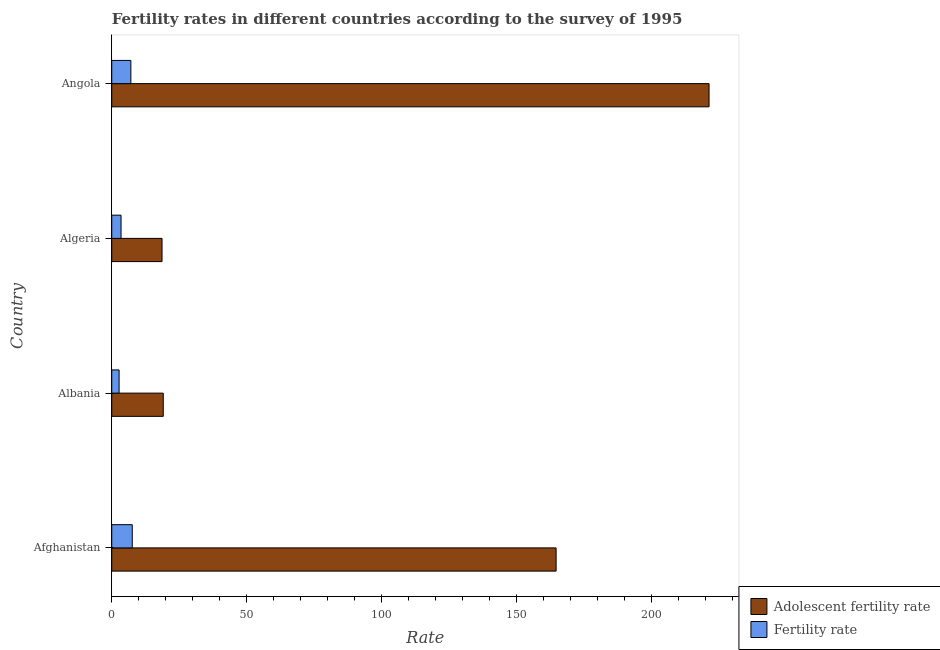Are the number of bars on each tick of the Y-axis equal?
Your answer should be compact. Yes. How many bars are there on the 1st tick from the top?
Your answer should be compact. 2. What is the label of the 4th group of bars from the top?
Keep it short and to the point. Afghanistan. What is the adolescent fertility rate in Albania?
Your response must be concise. 19.09. Across all countries, what is the maximum adolescent fertility rate?
Give a very brief answer. 221.4. Across all countries, what is the minimum fertility rate?
Keep it short and to the point. 2.72. In which country was the fertility rate maximum?
Your response must be concise. Afghanistan. In which country was the fertility rate minimum?
Offer a terse response. Albania. What is the total adolescent fertility rate in the graph?
Ensure brevity in your answer.  423.84. What is the difference between the adolescent fertility rate in Albania and that in Algeria?
Make the answer very short. 0.45. What is the difference between the adolescent fertility rate in Albania and the fertility rate in Afghanistan?
Your response must be concise. 11.49. What is the average adolescent fertility rate per country?
Provide a succinct answer. 105.96. What is the difference between the adolescent fertility rate and fertility rate in Algeria?
Offer a very short reply. 15.19. What is the ratio of the adolescent fertility rate in Algeria to that in Angola?
Your response must be concise. 0.08. Is the adolescent fertility rate in Albania less than that in Angola?
Provide a succinct answer. Yes. Is the difference between the adolescent fertility rate in Afghanistan and Angola greater than the difference between the fertility rate in Afghanistan and Angola?
Your answer should be compact. No. What is the difference between the highest and the second highest adolescent fertility rate?
Provide a short and direct response. 56.69. What is the difference between the highest and the lowest adolescent fertility rate?
Give a very brief answer. 202.76. In how many countries, is the adolescent fertility rate greater than the average adolescent fertility rate taken over all countries?
Keep it short and to the point. 2. What does the 2nd bar from the top in Algeria represents?
Keep it short and to the point. Adolescent fertility rate. What does the 2nd bar from the bottom in Algeria represents?
Your response must be concise. Fertility rate. How many countries are there in the graph?
Offer a terse response. 4. Does the graph contain grids?
Your response must be concise. No. What is the title of the graph?
Provide a short and direct response. Fertility rates in different countries according to the survey of 1995. Does "Primary income" appear as one of the legend labels in the graph?
Offer a very short reply. No. What is the label or title of the X-axis?
Give a very brief answer. Rate. What is the label or title of the Y-axis?
Provide a short and direct response. Country. What is the Rate of Adolescent fertility rate in Afghanistan?
Keep it short and to the point. 164.71. What is the Rate in Fertility rate in Afghanistan?
Keep it short and to the point. 7.61. What is the Rate of Adolescent fertility rate in Albania?
Make the answer very short. 19.09. What is the Rate in Fertility rate in Albania?
Ensure brevity in your answer.  2.72. What is the Rate of Adolescent fertility rate in Algeria?
Your answer should be compact. 18.64. What is the Rate of Fertility rate in Algeria?
Provide a succinct answer. 3.45. What is the Rate in Adolescent fertility rate in Angola?
Provide a succinct answer. 221.4. What is the Rate in Fertility rate in Angola?
Keep it short and to the point. 7.08. Across all countries, what is the maximum Rate in Adolescent fertility rate?
Make the answer very short. 221.4. Across all countries, what is the maximum Rate of Fertility rate?
Ensure brevity in your answer.  7.61. Across all countries, what is the minimum Rate of Adolescent fertility rate?
Provide a succinct answer. 18.64. Across all countries, what is the minimum Rate of Fertility rate?
Keep it short and to the point. 2.72. What is the total Rate of Adolescent fertility rate in the graph?
Provide a short and direct response. 423.84. What is the total Rate of Fertility rate in the graph?
Keep it short and to the point. 20.86. What is the difference between the Rate of Adolescent fertility rate in Afghanistan and that in Albania?
Your answer should be very brief. 145.62. What is the difference between the Rate in Fertility rate in Afghanistan and that in Albania?
Your answer should be very brief. 4.88. What is the difference between the Rate of Adolescent fertility rate in Afghanistan and that in Algeria?
Keep it short and to the point. 146.07. What is the difference between the Rate in Fertility rate in Afghanistan and that in Algeria?
Give a very brief answer. 4.16. What is the difference between the Rate in Adolescent fertility rate in Afghanistan and that in Angola?
Provide a succinct answer. -56.69. What is the difference between the Rate in Fertility rate in Afghanistan and that in Angola?
Make the answer very short. 0.52. What is the difference between the Rate of Adolescent fertility rate in Albania and that in Algeria?
Give a very brief answer. 0.45. What is the difference between the Rate of Fertility rate in Albania and that in Algeria?
Give a very brief answer. -0.72. What is the difference between the Rate in Adolescent fertility rate in Albania and that in Angola?
Offer a very short reply. -202.31. What is the difference between the Rate of Fertility rate in Albania and that in Angola?
Ensure brevity in your answer.  -4.36. What is the difference between the Rate in Adolescent fertility rate in Algeria and that in Angola?
Give a very brief answer. -202.76. What is the difference between the Rate of Fertility rate in Algeria and that in Angola?
Provide a succinct answer. -3.63. What is the difference between the Rate of Adolescent fertility rate in Afghanistan and the Rate of Fertility rate in Albania?
Offer a terse response. 161.99. What is the difference between the Rate in Adolescent fertility rate in Afghanistan and the Rate in Fertility rate in Algeria?
Ensure brevity in your answer.  161.26. What is the difference between the Rate of Adolescent fertility rate in Afghanistan and the Rate of Fertility rate in Angola?
Offer a very short reply. 157.63. What is the difference between the Rate of Adolescent fertility rate in Albania and the Rate of Fertility rate in Algeria?
Give a very brief answer. 15.64. What is the difference between the Rate in Adolescent fertility rate in Albania and the Rate in Fertility rate in Angola?
Make the answer very short. 12.01. What is the difference between the Rate of Adolescent fertility rate in Algeria and the Rate of Fertility rate in Angola?
Your answer should be very brief. 11.56. What is the average Rate of Adolescent fertility rate per country?
Your response must be concise. 105.96. What is the average Rate of Fertility rate per country?
Give a very brief answer. 5.21. What is the difference between the Rate in Adolescent fertility rate and Rate in Fertility rate in Afghanistan?
Give a very brief answer. 157.11. What is the difference between the Rate of Adolescent fertility rate and Rate of Fertility rate in Albania?
Your answer should be very brief. 16.37. What is the difference between the Rate of Adolescent fertility rate and Rate of Fertility rate in Algeria?
Make the answer very short. 15.19. What is the difference between the Rate of Adolescent fertility rate and Rate of Fertility rate in Angola?
Offer a terse response. 214.32. What is the ratio of the Rate in Adolescent fertility rate in Afghanistan to that in Albania?
Keep it short and to the point. 8.63. What is the ratio of the Rate in Fertility rate in Afghanistan to that in Albania?
Ensure brevity in your answer.  2.79. What is the ratio of the Rate in Adolescent fertility rate in Afghanistan to that in Algeria?
Give a very brief answer. 8.84. What is the ratio of the Rate in Fertility rate in Afghanistan to that in Algeria?
Give a very brief answer. 2.21. What is the ratio of the Rate of Adolescent fertility rate in Afghanistan to that in Angola?
Provide a succinct answer. 0.74. What is the ratio of the Rate of Fertility rate in Afghanistan to that in Angola?
Provide a succinct answer. 1.07. What is the ratio of the Rate of Adolescent fertility rate in Albania to that in Algeria?
Provide a succinct answer. 1.02. What is the ratio of the Rate of Fertility rate in Albania to that in Algeria?
Keep it short and to the point. 0.79. What is the ratio of the Rate of Adolescent fertility rate in Albania to that in Angola?
Your response must be concise. 0.09. What is the ratio of the Rate in Fertility rate in Albania to that in Angola?
Your answer should be very brief. 0.38. What is the ratio of the Rate of Adolescent fertility rate in Algeria to that in Angola?
Give a very brief answer. 0.08. What is the ratio of the Rate in Fertility rate in Algeria to that in Angola?
Your response must be concise. 0.49. What is the difference between the highest and the second highest Rate in Adolescent fertility rate?
Give a very brief answer. 56.69. What is the difference between the highest and the second highest Rate of Fertility rate?
Provide a succinct answer. 0.52. What is the difference between the highest and the lowest Rate of Adolescent fertility rate?
Offer a very short reply. 202.76. What is the difference between the highest and the lowest Rate of Fertility rate?
Your answer should be very brief. 4.88. 